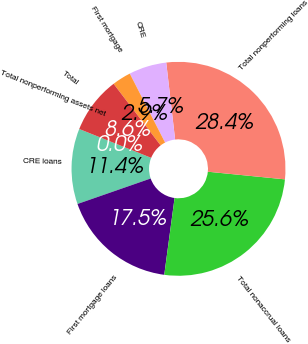Convert chart. <chart><loc_0><loc_0><loc_500><loc_500><pie_chart><fcel>CRE loans<fcel>First mortgage loans<fcel>Total nonaccrual loans<fcel>Total nonperforming loans<fcel>CRE<fcel>First mortgage<fcel>Total<fcel>Total nonperforming assets net<nl><fcel>11.4%<fcel>17.54%<fcel>25.55%<fcel>28.4%<fcel>5.7%<fcel>2.85%<fcel>8.55%<fcel>0.0%<nl></chart> 